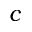Convert formula to latex. <formula><loc_0><loc_0><loc_500><loc_500>c</formula> 